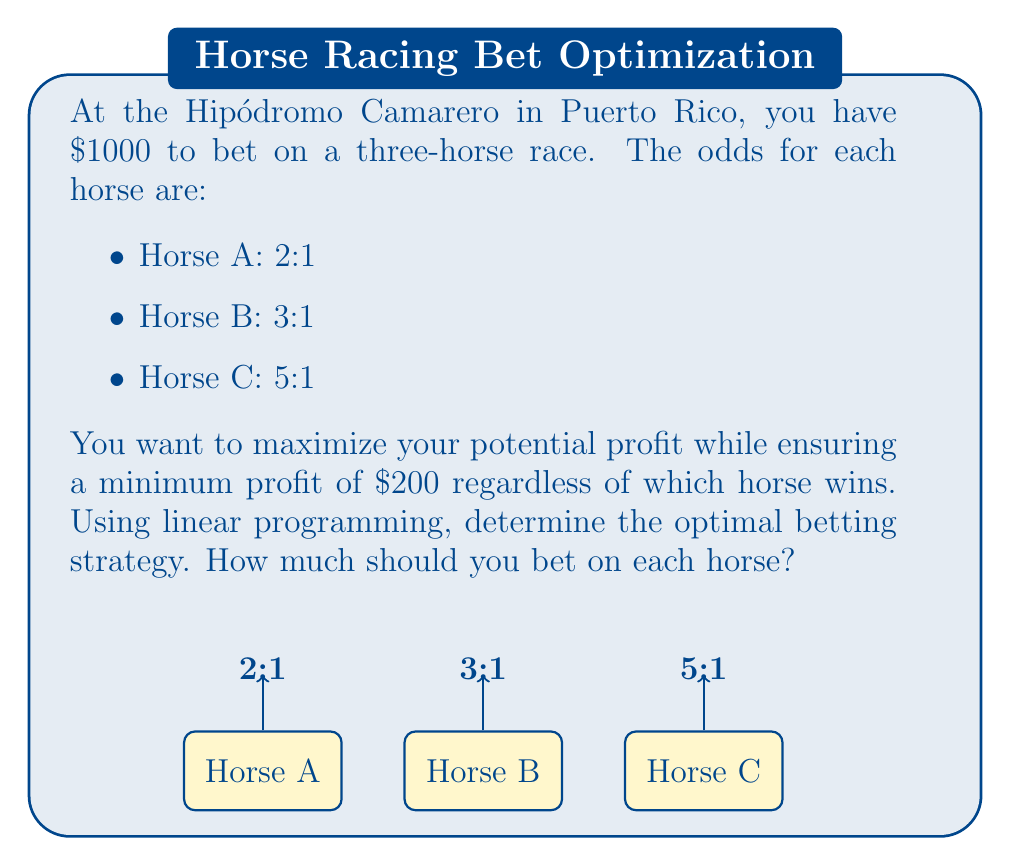Can you solve this math problem? Let's solve this problem using linear programming:

1) Define variables:
   Let $x_A$, $x_B$, and $x_C$ be the amounts bet on Horse A, B, and C respectively.

2) Objective function:
   We want to maximize the potential profit. The objective function is:
   $$\text{Maximize } Z = 2x_A + 3x_B + 5x_C$$

3) Constraints:
   a) Total bet constraint:
      $$x_A + x_B + x_C \leq 1000$$
   
   b) Minimum profit constraints:
      For Horse A: $2x_A - x_B - x_C \geq 200$
      For Horse B: $-x_A + 3x_B - x_C \geq 200$
      For Horse C: $-x_A - x_B + 5x_C \geq 200$
   
   c) Non-negativity constraints:
      $x_A, x_B, x_C \geq 0$

4) Solve the linear programming problem:
   Using a solver (like simplex method), we get the optimal solution:
   $x_A = 400$, $x_B = 300$, $x_C = 300$

5) Verify the solution:
   - Total bet: $400 + 300 + 300 = 1000$ (satisfies constraint)
   - If Horse A wins: Profit = $2(400) - 300 - 300 = 200$
   - If Horse B wins: Profit = $-400 + 3(300) - 300 = 200$
   - If Horse C wins: Profit = $-400 - 300 + 5(300) = 800$

   All constraints are satisfied, and the minimum profit is guaranteed.

6) Calculate maximum potential profit:
   Maximum profit occurs if Horse C wins: $800

Therefore, the optimal betting strategy is to bet $400 on Horse A, $300 on Horse B, and $300 on Horse C.
Answer: Bet $400 on Horse A, $300 on Horse B, and $300 on Horse C. 